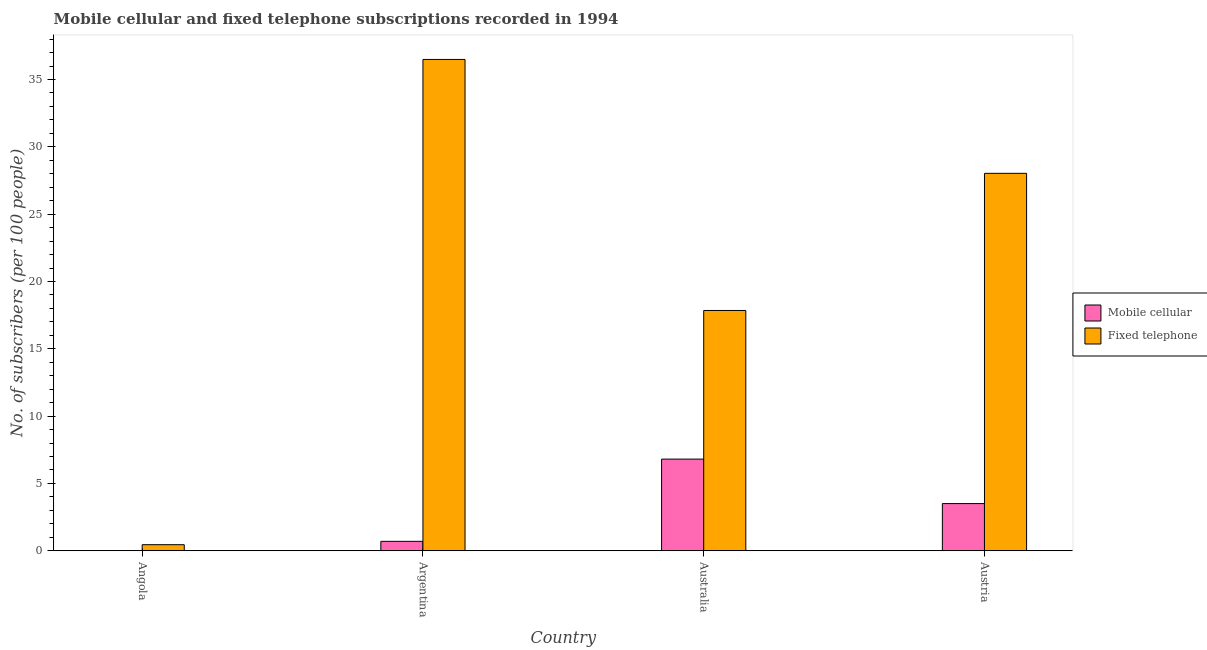How many different coloured bars are there?
Keep it short and to the point. 2. How many groups of bars are there?
Offer a terse response. 4. Are the number of bars on each tick of the X-axis equal?
Ensure brevity in your answer.  Yes. How many bars are there on the 1st tick from the right?
Offer a terse response. 2. What is the label of the 2nd group of bars from the left?
Provide a short and direct response. Argentina. In how many cases, is the number of bars for a given country not equal to the number of legend labels?
Your answer should be compact. 0. What is the number of mobile cellular subscribers in Australia?
Your response must be concise. 6.81. Across all countries, what is the maximum number of mobile cellular subscribers?
Your answer should be very brief. 6.81. Across all countries, what is the minimum number of mobile cellular subscribers?
Keep it short and to the point. 0.02. In which country was the number of fixed telephone subscribers minimum?
Provide a short and direct response. Angola. What is the total number of mobile cellular subscribers in the graph?
Provide a short and direct response. 11.03. What is the difference between the number of mobile cellular subscribers in Argentina and that in Austria?
Provide a short and direct response. -2.8. What is the difference between the number of fixed telephone subscribers in Australia and the number of mobile cellular subscribers in Argentina?
Provide a succinct answer. 17.14. What is the average number of fixed telephone subscribers per country?
Keep it short and to the point. 20.7. What is the difference between the number of mobile cellular subscribers and number of fixed telephone subscribers in Austria?
Provide a short and direct response. -24.53. In how many countries, is the number of fixed telephone subscribers greater than 23 ?
Your answer should be very brief. 2. What is the ratio of the number of fixed telephone subscribers in Australia to that in Austria?
Your response must be concise. 0.64. Is the number of fixed telephone subscribers in Angola less than that in Australia?
Provide a succinct answer. Yes. What is the difference between the highest and the second highest number of mobile cellular subscribers?
Offer a terse response. 3.3. What is the difference between the highest and the lowest number of fixed telephone subscribers?
Offer a terse response. 36.04. In how many countries, is the number of fixed telephone subscribers greater than the average number of fixed telephone subscribers taken over all countries?
Your answer should be very brief. 2. What does the 2nd bar from the left in Angola represents?
Offer a very short reply. Fixed telephone. What does the 2nd bar from the right in Austria represents?
Provide a succinct answer. Mobile cellular. Are all the bars in the graph horizontal?
Offer a very short reply. No. What is the difference between two consecutive major ticks on the Y-axis?
Ensure brevity in your answer.  5. Are the values on the major ticks of Y-axis written in scientific E-notation?
Offer a terse response. No. Where does the legend appear in the graph?
Make the answer very short. Center right. What is the title of the graph?
Ensure brevity in your answer.  Mobile cellular and fixed telephone subscriptions recorded in 1994. Does "Sanitation services" appear as one of the legend labels in the graph?
Give a very brief answer. No. What is the label or title of the Y-axis?
Offer a very short reply. No. of subscribers (per 100 people). What is the No. of subscribers (per 100 people) in Mobile cellular in Angola?
Ensure brevity in your answer.  0.02. What is the No. of subscribers (per 100 people) of Fixed telephone in Angola?
Keep it short and to the point. 0.45. What is the No. of subscribers (per 100 people) in Mobile cellular in Argentina?
Your answer should be compact. 0.7. What is the No. of subscribers (per 100 people) in Fixed telephone in Argentina?
Your response must be concise. 36.49. What is the No. of subscribers (per 100 people) of Mobile cellular in Australia?
Your answer should be compact. 6.81. What is the No. of subscribers (per 100 people) in Fixed telephone in Australia?
Offer a very short reply. 17.85. What is the No. of subscribers (per 100 people) of Mobile cellular in Austria?
Your answer should be very brief. 3.5. What is the No. of subscribers (per 100 people) of Fixed telephone in Austria?
Keep it short and to the point. 28.03. Across all countries, what is the maximum No. of subscribers (per 100 people) of Mobile cellular?
Ensure brevity in your answer.  6.81. Across all countries, what is the maximum No. of subscribers (per 100 people) in Fixed telephone?
Offer a terse response. 36.49. Across all countries, what is the minimum No. of subscribers (per 100 people) of Mobile cellular?
Your answer should be compact. 0.02. Across all countries, what is the minimum No. of subscribers (per 100 people) in Fixed telephone?
Provide a short and direct response. 0.45. What is the total No. of subscribers (per 100 people) of Mobile cellular in the graph?
Offer a very short reply. 11.03. What is the total No. of subscribers (per 100 people) of Fixed telephone in the graph?
Make the answer very short. 82.82. What is the difference between the No. of subscribers (per 100 people) in Mobile cellular in Angola and that in Argentina?
Your answer should be compact. -0.69. What is the difference between the No. of subscribers (per 100 people) in Fixed telephone in Angola and that in Argentina?
Your answer should be compact. -36.04. What is the difference between the No. of subscribers (per 100 people) in Mobile cellular in Angola and that in Australia?
Offer a terse response. -6.79. What is the difference between the No. of subscribers (per 100 people) in Fixed telephone in Angola and that in Australia?
Keep it short and to the point. -17.39. What is the difference between the No. of subscribers (per 100 people) in Mobile cellular in Angola and that in Austria?
Keep it short and to the point. -3.49. What is the difference between the No. of subscribers (per 100 people) in Fixed telephone in Angola and that in Austria?
Make the answer very short. -27.58. What is the difference between the No. of subscribers (per 100 people) in Mobile cellular in Argentina and that in Australia?
Keep it short and to the point. -6.11. What is the difference between the No. of subscribers (per 100 people) in Fixed telephone in Argentina and that in Australia?
Your response must be concise. 18.64. What is the difference between the No. of subscribers (per 100 people) in Mobile cellular in Argentina and that in Austria?
Make the answer very short. -2.8. What is the difference between the No. of subscribers (per 100 people) in Fixed telephone in Argentina and that in Austria?
Your answer should be compact. 8.46. What is the difference between the No. of subscribers (per 100 people) in Mobile cellular in Australia and that in Austria?
Make the answer very short. 3.3. What is the difference between the No. of subscribers (per 100 people) in Fixed telephone in Australia and that in Austria?
Your answer should be very brief. -10.19. What is the difference between the No. of subscribers (per 100 people) of Mobile cellular in Angola and the No. of subscribers (per 100 people) of Fixed telephone in Argentina?
Your answer should be very brief. -36.47. What is the difference between the No. of subscribers (per 100 people) in Mobile cellular in Angola and the No. of subscribers (per 100 people) in Fixed telephone in Australia?
Keep it short and to the point. -17.83. What is the difference between the No. of subscribers (per 100 people) in Mobile cellular in Angola and the No. of subscribers (per 100 people) in Fixed telephone in Austria?
Keep it short and to the point. -28.02. What is the difference between the No. of subscribers (per 100 people) of Mobile cellular in Argentina and the No. of subscribers (per 100 people) of Fixed telephone in Australia?
Offer a terse response. -17.14. What is the difference between the No. of subscribers (per 100 people) in Mobile cellular in Argentina and the No. of subscribers (per 100 people) in Fixed telephone in Austria?
Give a very brief answer. -27.33. What is the difference between the No. of subscribers (per 100 people) of Mobile cellular in Australia and the No. of subscribers (per 100 people) of Fixed telephone in Austria?
Provide a short and direct response. -21.22. What is the average No. of subscribers (per 100 people) in Mobile cellular per country?
Your response must be concise. 2.76. What is the average No. of subscribers (per 100 people) in Fixed telephone per country?
Your response must be concise. 20.7. What is the difference between the No. of subscribers (per 100 people) of Mobile cellular and No. of subscribers (per 100 people) of Fixed telephone in Angola?
Your answer should be very brief. -0.44. What is the difference between the No. of subscribers (per 100 people) in Mobile cellular and No. of subscribers (per 100 people) in Fixed telephone in Argentina?
Keep it short and to the point. -35.79. What is the difference between the No. of subscribers (per 100 people) of Mobile cellular and No. of subscribers (per 100 people) of Fixed telephone in Australia?
Offer a very short reply. -11.04. What is the difference between the No. of subscribers (per 100 people) of Mobile cellular and No. of subscribers (per 100 people) of Fixed telephone in Austria?
Offer a terse response. -24.53. What is the ratio of the No. of subscribers (per 100 people) of Mobile cellular in Angola to that in Argentina?
Your answer should be compact. 0.02. What is the ratio of the No. of subscribers (per 100 people) in Fixed telephone in Angola to that in Argentina?
Provide a succinct answer. 0.01. What is the ratio of the No. of subscribers (per 100 people) in Mobile cellular in Angola to that in Australia?
Ensure brevity in your answer.  0. What is the ratio of the No. of subscribers (per 100 people) of Fixed telephone in Angola to that in Australia?
Your response must be concise. 0.03. What is the ratio of the No. of subscribers (per 100 people) of Mobile cellular in Angola to that in Austria?
Keep it short and to the point. 0. What is the ratio of the No. of subscribers (per 100 people) in Fixed telephone in Angola to that in Austria?
Your response must be concise. 0.02. What is the ratio of the No. of subscribers (per 100 people) of Mobile cellular in Argentina to that in Australia?
Provide a short and direct response. 0.1. What is the ratio of the No. of subscribers (per 100 people) of Fixed telephone in Argentina to that in Australia?
Ensure brevity in your answer.  2.04. What is the ratio of the No. of subscribers (per 100 people) in Fixed telephone in Argentina to that in Austria?
Ensure brevity in your answer.  1.3. What is the ratio of the No. of subscribers (per 100 people) in Mobile cellular in Australia to that in Austria?
Ensure brevity in your answer.  1.94. What is the ratio of the No. of subscribers (per 100 people) of Fixed telephone in Australia to that in Austria?
Your response must be concise. 0.64. What is the difference between the highest and the second highest No. of subscribers (per 100 people) in Mobile cellular?
Your answer should be very brief. 3.3. What is the difference between the highest and the second highest No. of subscribers (per 100 people) of Fixed telephone?
Provide a succinct answer. 8.46. What is the difference between the highest and the lowest No. of subscribers (per 100 people) of Mobile cellular?
Offer a very short reply. 6.79. What is the difference between the highest and the lowest No. of subscribers (per 100 people) of Fixed telephone?
Ensure brevity in your answer.  36.04. 